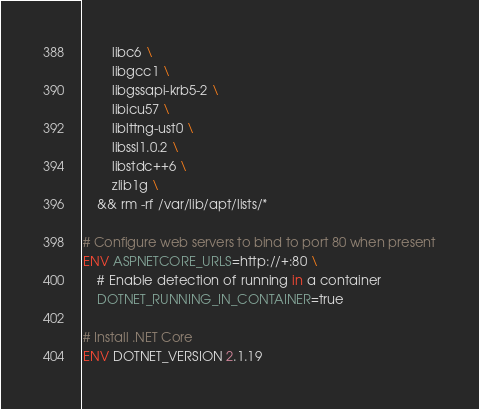Convert code to text. <code><loc_0><loc_0><loc_500><loc_500><_Dockerfile_>        libc6 \
        libgcc1 \
        libgssapi-krb5-2 \
        libicu57 \
        liblttng-ust0 \
        libssl1.0.2 \
        libstdc++6 \
        zlib1g \
    && rm -rf /var/lib/apt/lists/*

# Configure web servers to bind to port 80 when present
ENV ASPNETCORE_URLS=http://+:80 \
    # Enable detection of running in a container
    DOTNET_RUNNING_IN_CONTAINER=true

# Install .NET Core
ENV DOTNET_VERSION 2.1.19
</code> 